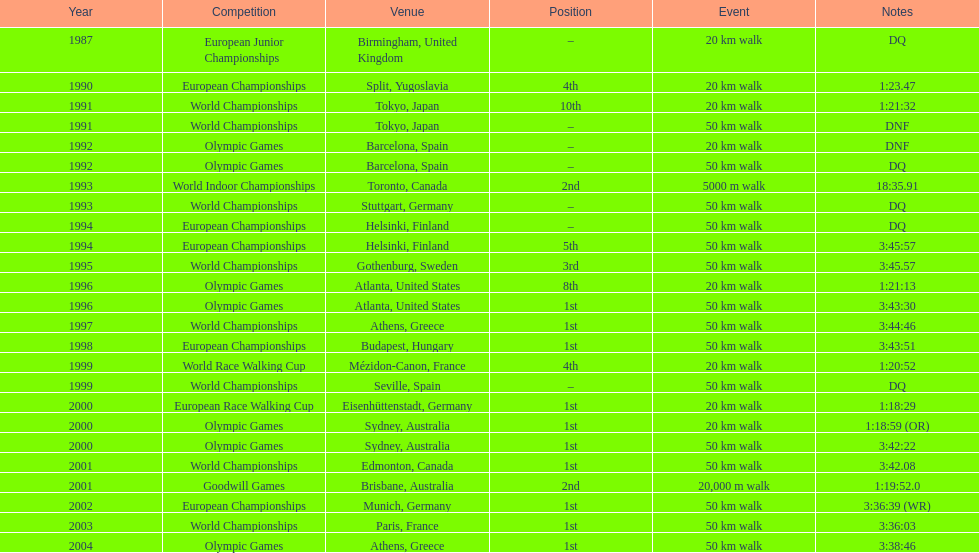How many events had a minimum distance of 50 km? 17. 